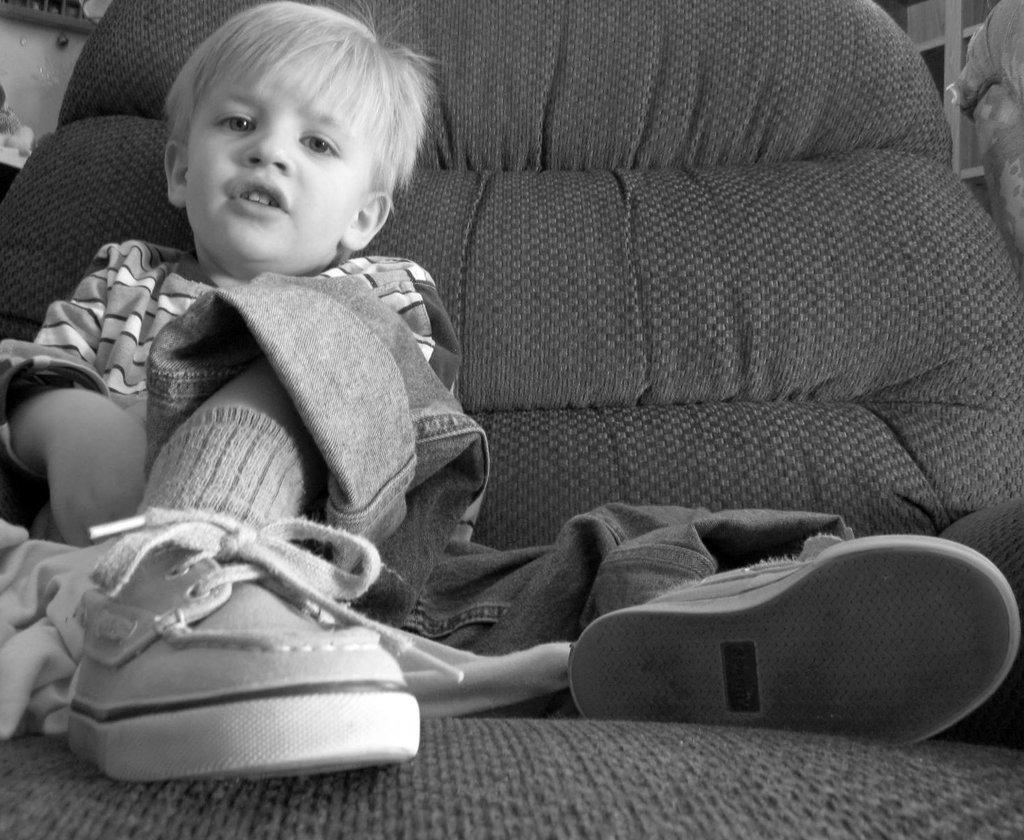Who is the main subject in the image? There is a boy in the image. What is the boy doing in the image? The boy is sitting on a sofa. What is the boy wearing on his feet? The boy is wearing shoes. What can be seen in the background of the image? There is a wall in the background of the image. How many cents are visible on the floor in the image? There are no cents visible on the floor in the image. What type of birthday celebration is taking place in the image? There is no birthday celebration present in the image. 